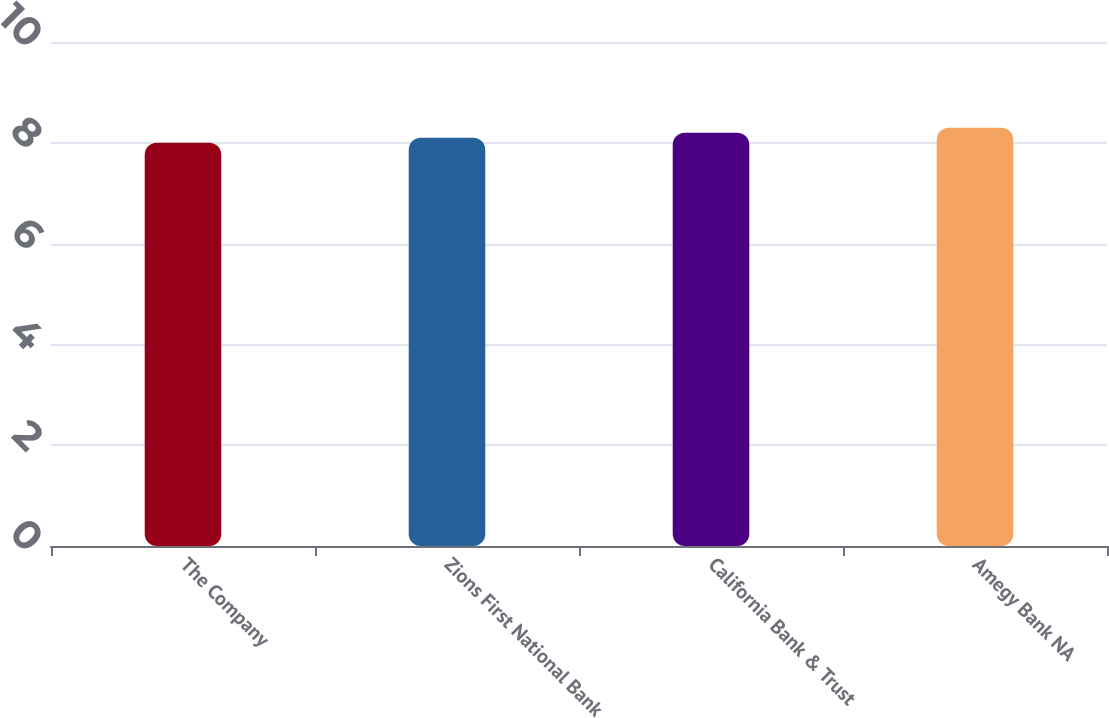<chart> <loc_0><loc_0><loc_500><loc_500><bar_chart><fcel>The Company<fcel>Zions First National Bank<fcel>California Bank & Trust<fcel>Amegy Bank NA<nl><fcel>8<fcel>8.1<fcel>8.2<fcel>8.3<nl></chart> 